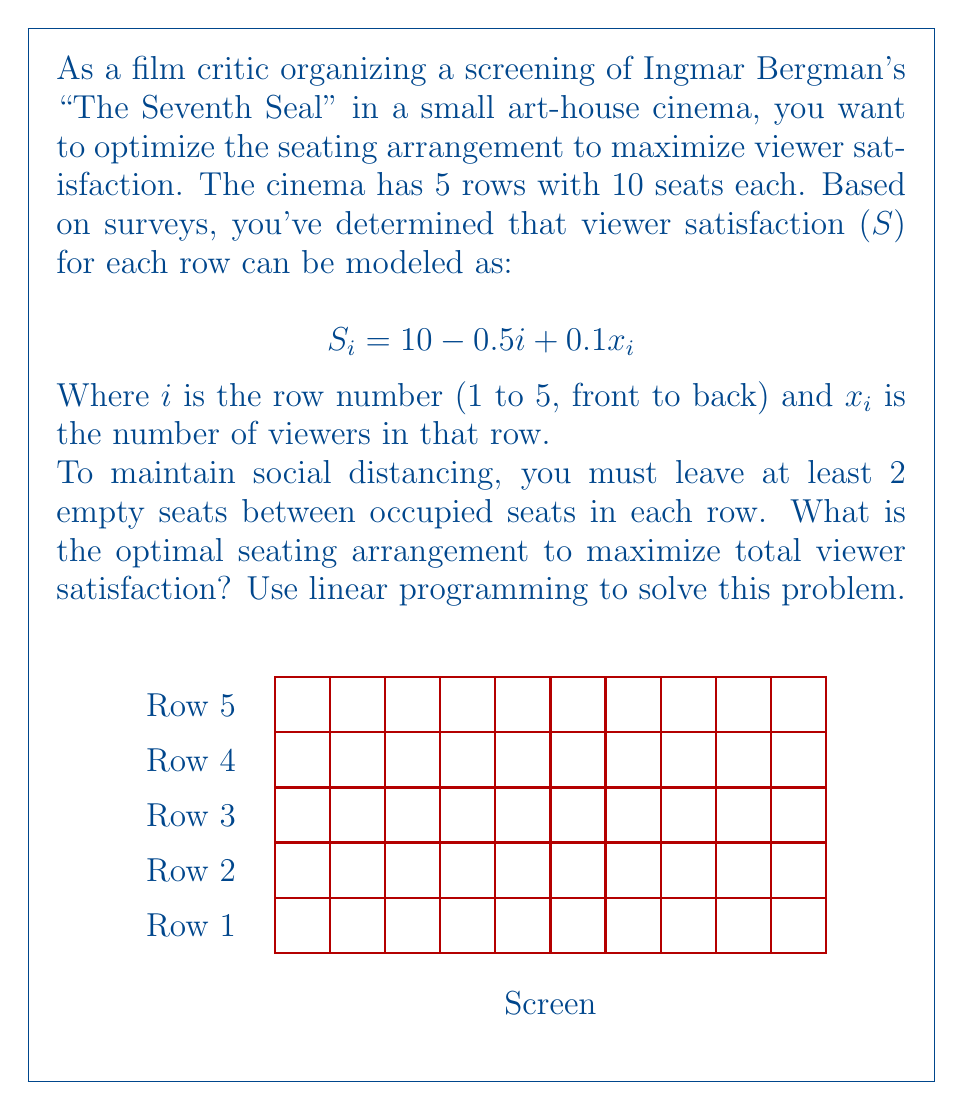Can you answer this question? Let's approach this step-by-step using linear programming:

1) Define variables:
   $x_i$ = number of viewers in row $i$ (1 ≤ i ≤ 5)

2) Objective function:
   Maximize total satisfaction: 
   $$S_{total} = \sum_{i=1}^5 S_i = \sum_{i=1}^5 (10 - 0.5i + 0.1x_i)$$

3) Constraints:
   a) Social distancing: Each row can have at most 3 viewers (seats 1, 4, 7 or 2, 5, 8 or 3, 6, 9)
      $0 \leq x_i \leq 3$ for all $i$
   
   b) Integer constraint: $x_i$ must be integers

4) Simplify the objective function:
   $$S_{total} = \sum_{i=1}^5 (10 - 0.5i + 0.1x_i)$$
   $$= (10 - 0.5(1) + 0.1x_1) + (10 - 0.5(2) + 0.1x_2) + ... + (10 - 0.5(5) + 0.1x_5)$$
   $$= 37.5 + 0.1(x_1 + x_2 + x_3 + x_4 + x_5)$$

5) The problem becomes:
   Maximize: $37.5 + 0.1(x_1 + x_2 + x_3 + x_4 + x_5)$
   Subject to: $0 \leq x_i \leq 3$ and $x_i$ are integers for all $i$

6) Solution:
   To maximize the objective function, we need to maximize each $x_i$. Given the constraints, the optimal solution is:
   $x_1 = x_2 = x_3 = x_4 = x_5 = 3$

7) Calculate total satisfaction:
   $S_{total} = 37.5 + 0.1(3 + 3 + 3 + 3 + 3) = 37.5 + 1.5 = 39$

Therefore, the optimal seating arrangement is to place 3 viewers in each row, maximizing total satisfaction at 39.
Answer: 3 viewers in each row; Total satisfaction = 39 